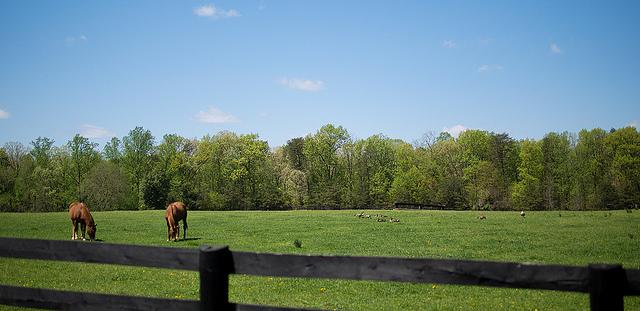What other type of large animal might be found in this environment? Please explain your reasoning. cow. These are grazing animals as well, so it makes sense they'd be in the same place. 